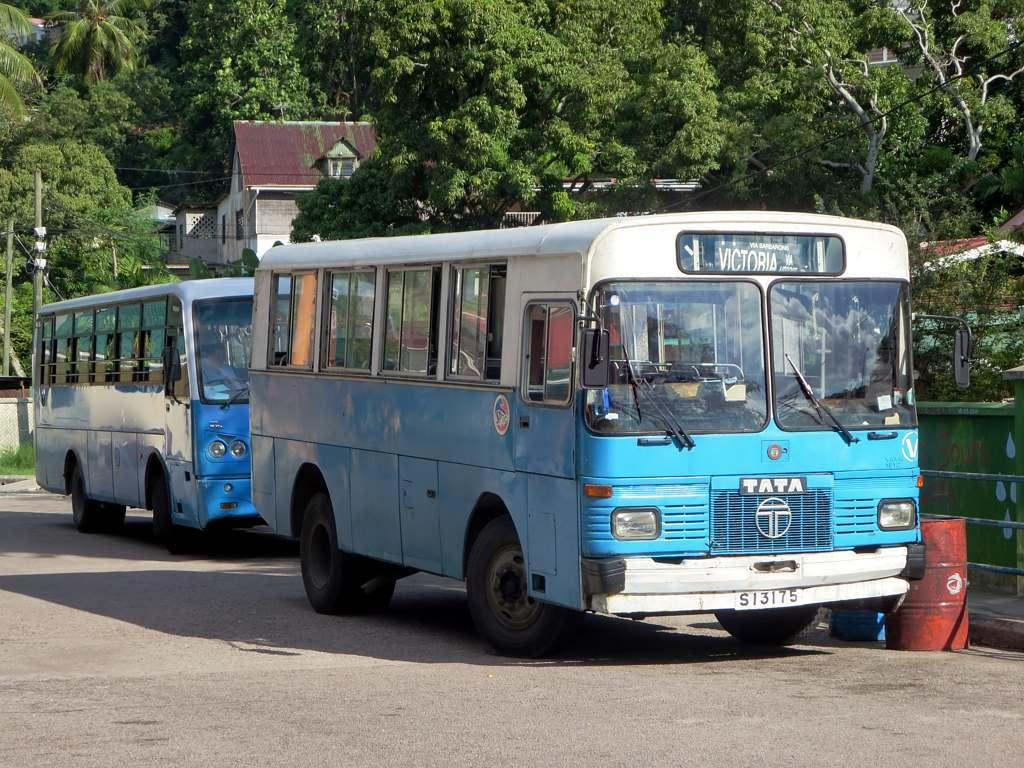What type of vehicles can be seen on the road in the image? There are two buses on the road in the image. Where are the buses located in the image? The buses are located at the bottom of the image. What structure is in the middle of the image? There is a building in the middle of the image. What can be seen in the background of the image? There are trees in the background of the image. Can you tell me which expert is wearing a cap in the image? There is no expert or cap present in the image; it features buses on the road and a building in the middle. What type of chain can be seen connecting the buses in the image? There is no chain connecting the buses in the image; they are separate vehicles on the road. 